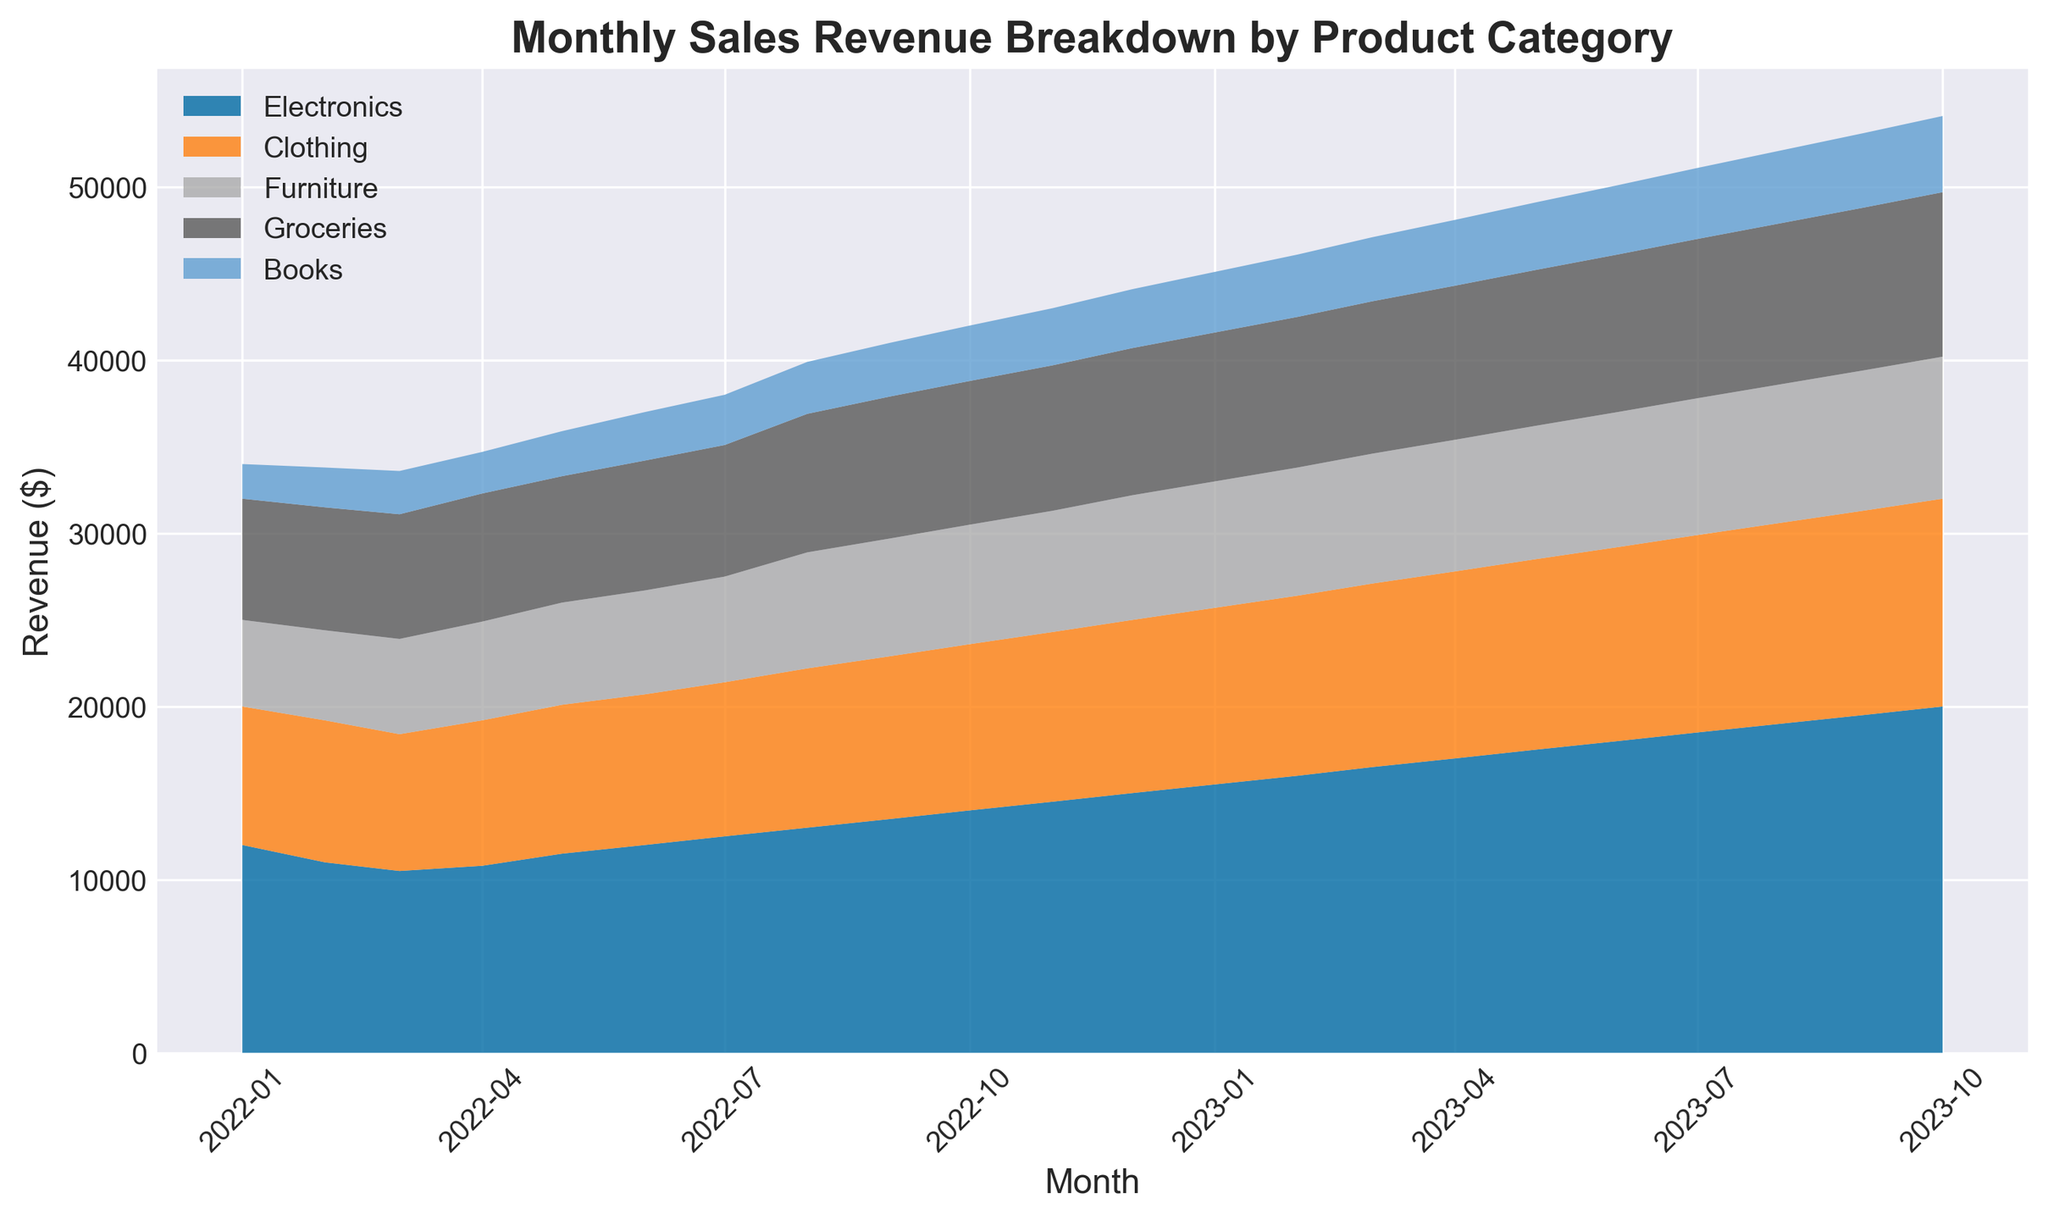What is the total revenue generated in January 2023 from all product categories? To find the total revenue in January 2023, sum the revenues from all product categories for that month: Electronics ($15,500) + Clothing ($10,200) + Furniture ($7,300) + Groceries ($8,600) + Books ($3,500).
Answer: $45,100 Which product category showed the highest sales growth between January 2022 and October 2023? Subtract the revenue in January 2022 from the revenue in October 2023 for each category and determine which has the largest increase. Clothing's increase ($12,000 - $8,000) is $4,000, highest among all categories.
Answer: Clothing How did the revenue from Groceries change from February 2023 to July 2023 – increase or decrease? Look at the revenue from Groceries in February 2023 ($8,700) and compare it with July 2023 ($9,200).
Answer: Increase Which month had the highest total revenue across all product categories? Add the revenue from all product categories for each month and identify which month has the highest total. October 2023 has: $20,000 + $12,000 + $8,200 + $9,500 + $4,400 = $54,100.
Answer: October 2023 Which product category consistently increased its revenue from January 2022 to October 2023? Examine the trend lines for each product category from January 2022 to October 2023. All categories show consistent increase, but Electronics is the highest at every checkpoint without decrease.
Answer: Electronics By how much did the sales revenue of Books in April 2023 differ from that in April 2022? Subtract the revenue of Books in April 2022 ($2,400) from that in April 2023 ($3,800).
Answer: $1,400 What was the total increase in revenue for Furniture between June 2022 and June 2023? Subtract the revenue of Furniture in June 2022 ($6,000) from that in June 2023 ($7,800).
Answer: $1,800 Which category showed the least variation in monthly sales revenue from January 2022 to October 2023? Compare the range (difference between maximum and minimum values) of monthly sales revenue for each category. Books have the smallest range from $2,000 to $4,400, which is $2,400.
Answer: Books Has the revenue from Electronics reached a peak by October 2023, or is there still an increasing trend? Observe the trend line for the Electronics category; it has been consistently increasing till October 2023 without showing any signs of plateauing.
Answer: Increasing trend What is the difference between the highest and lowest monthly total sales revenue in 2023? Calculate the total revenue for each month in 2023, and identify the highest and lowest values. Highest is October 2023 ($54,100) and lowest is January 2023 ($45,100). Difference: $54,100 - $45,100.
Answer: $9,000 